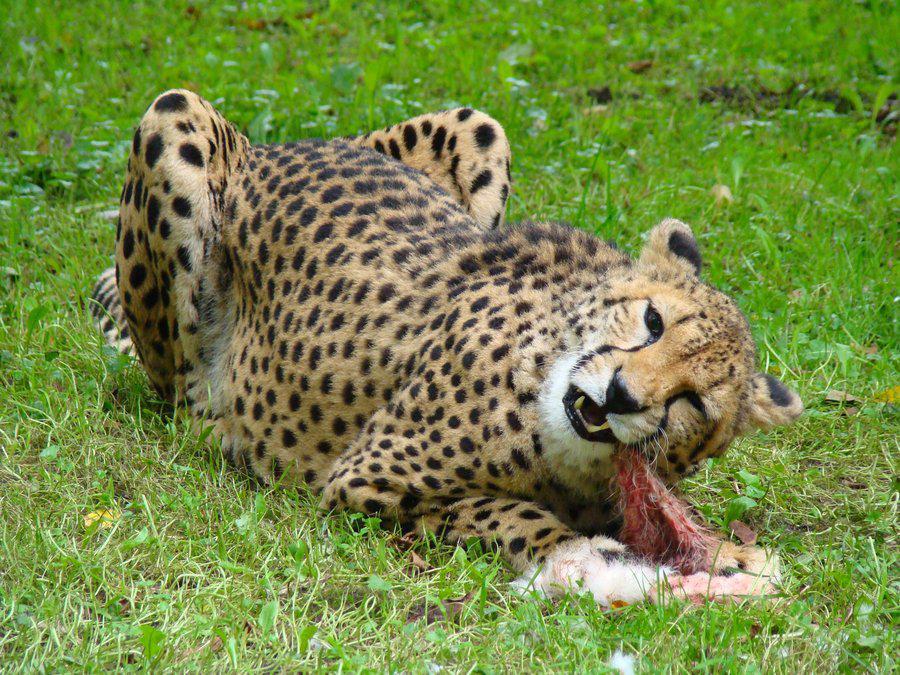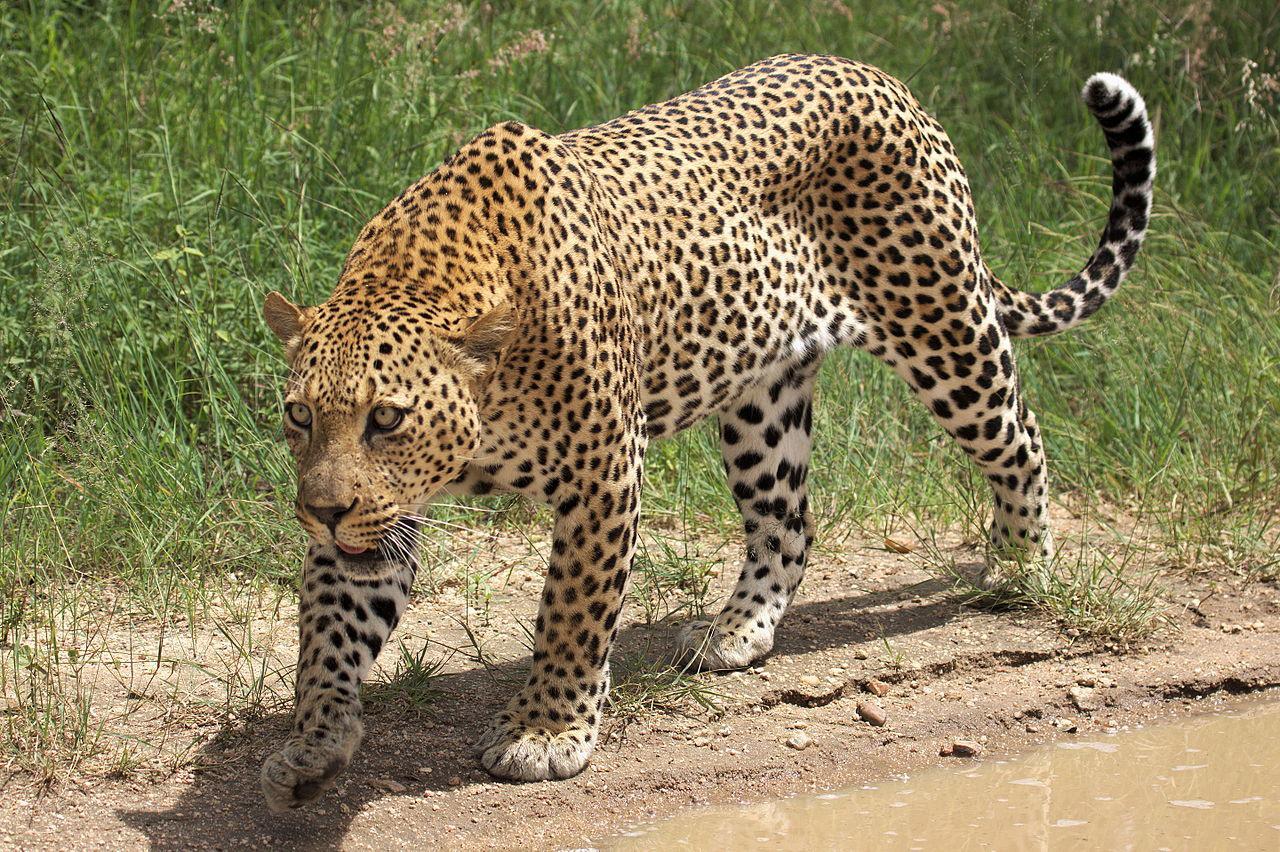The first image is the image on the left, the second image is the image on the right. For the images displayed, is the sentence "In at least one image there is a dead elk will all four if its legs in front of a cheetah." factually correct? Answer yes or no. No. 